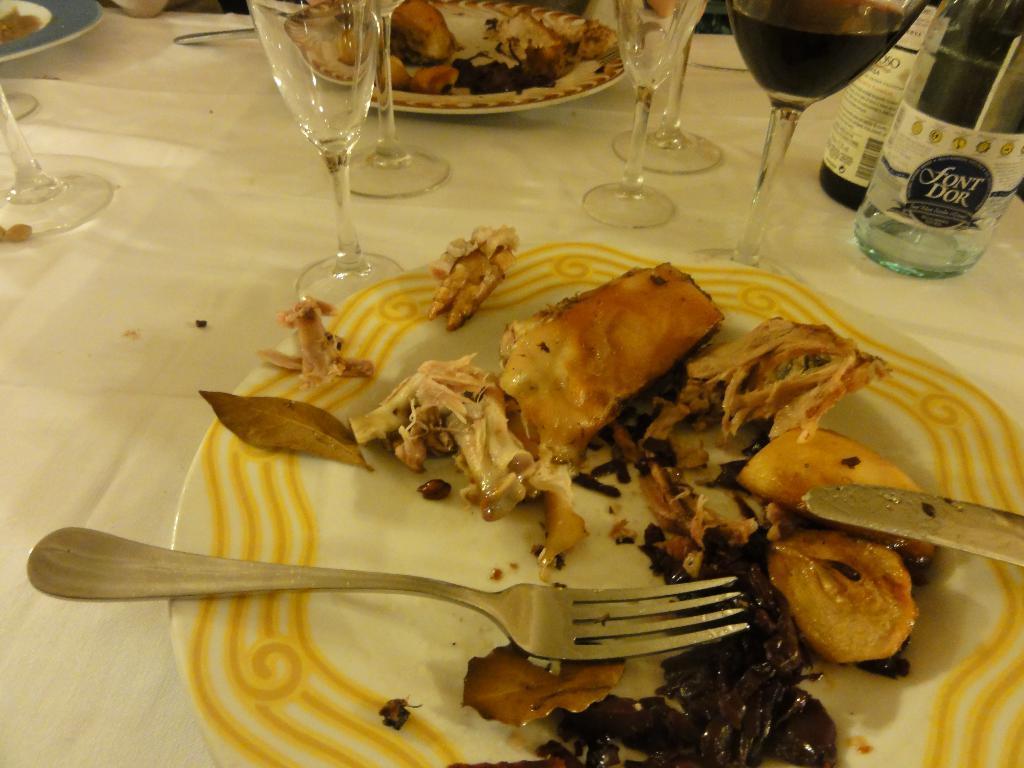Describe this image in one or two sentences. This image consists of plate, glasses, bottle, fork, knife. On the plate there are eatables. 